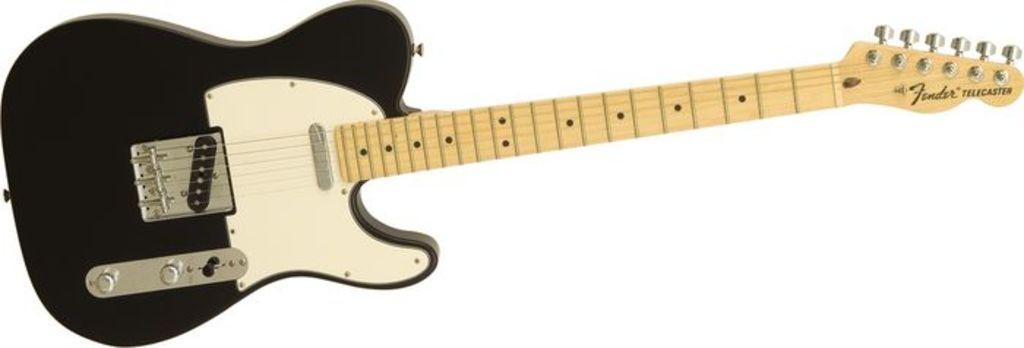How would you summarize this image in a sentence or two? There is a guitar in the given picture. It is in black and yellow color. 